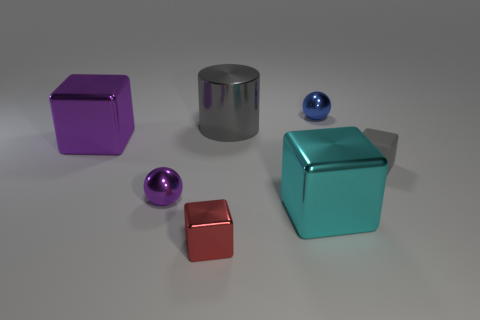The other shiny object that is the same shape as the tiny blue metallic object is what color?
Make the answer very short. Purple. How many small things have the same color as the big metallic cylinder?
Provide a succinct answer. 1. Is there a large purple thing behind the tiny metallic sphere that is behind the gray rubber thing?
Offer a very short reply. No. What number of blocks are both right of the purple cube and on the left side of the gray matte thing?
Offer a terse response. 2. What number of yellow balls have the same material as the big gray cylinder?
Keep it short and to the point. 0. There is a block right of the large cube in front of the gray rubber cube; what size is it?
Make the answer very short. Small. Is there a big red rubber thing of the same shape as the large purple metallic object?
Give a very brief answer. No. There is a sphere to the left of the small blue thing; is its size the same as the metal cube that is behind the cyan object?
Give a very brief answer. No. Is the number of metallic blocks behind the small gray matte thing less than the number of blue objects left of the purple sphere?
Provide a short and direct response. No. There is a thing that is the same color as the large cylinder; what is its material?
Give a very brief answer. Rubber. 